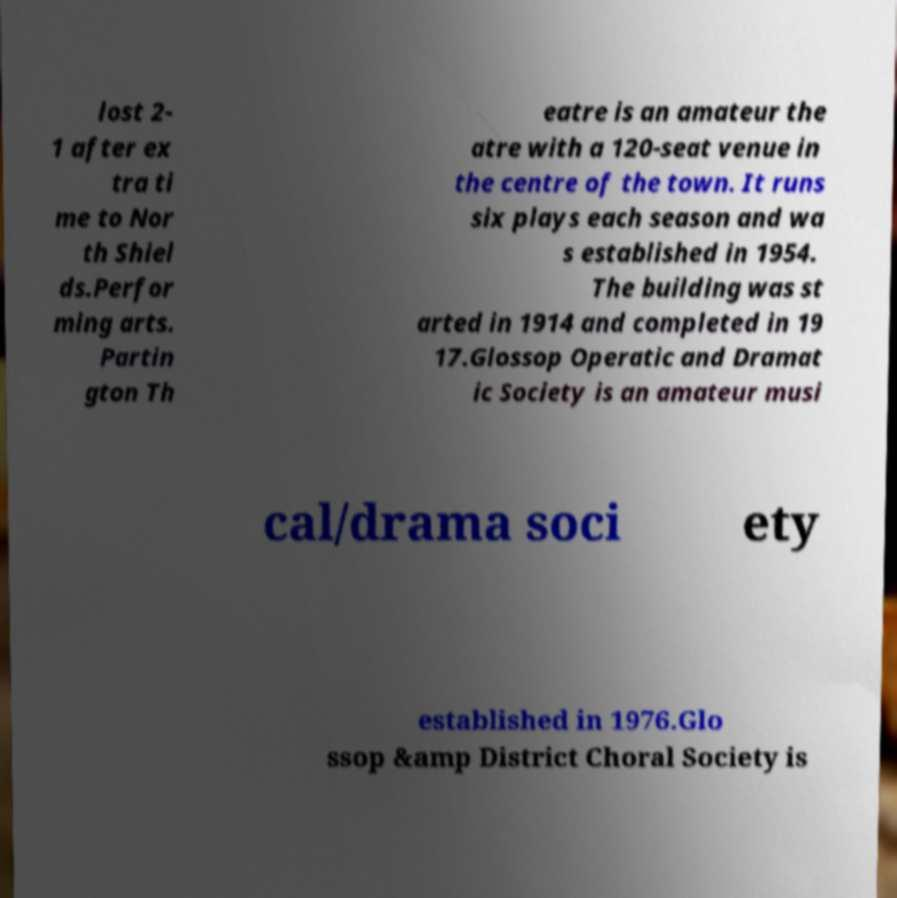Can you read and provide the text displayed in the image?This photo seems to have some interesting text. Can you extract and type it out for me? lost 2- 1 after ex tra ti me to Nor th Shiel ds.Perfor ming arts. Partin gton Th eatre is an amateur the atre with a 120-seat venue in the centre of the town. It runs six plays each season and wa s established in 1954. The building was st arted in 1914 and completed in 19 17.Glossop Operatic and Dramat ic Society is an amateur musi cal/drama soci ety established in 1976.Glo ssop &amp District Choral Society is 